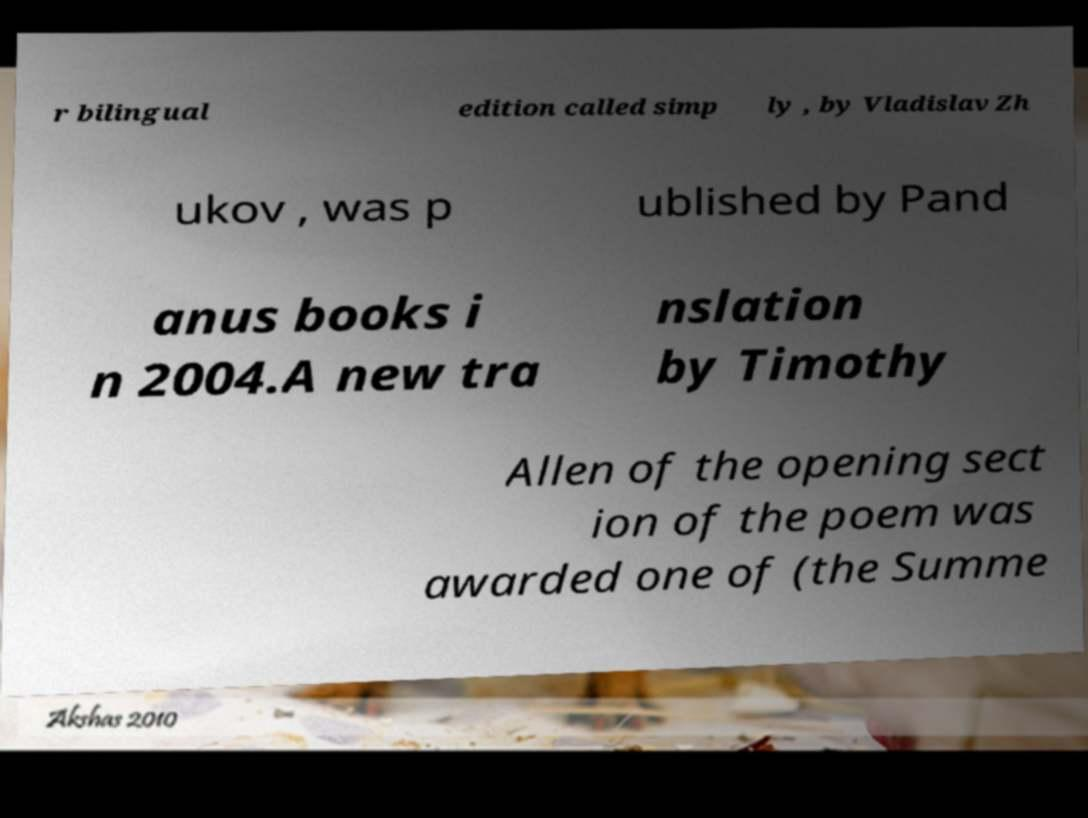Please read and relay the text visible in this image. What does it say? r bilingual edition called simp ly , by Vladislav Zh ukov , was p ublished by Pand anus books i n 2004.A new tra nslation by Timothy Allen of the opening sect ion of the poem was awarded one of (the Summe 